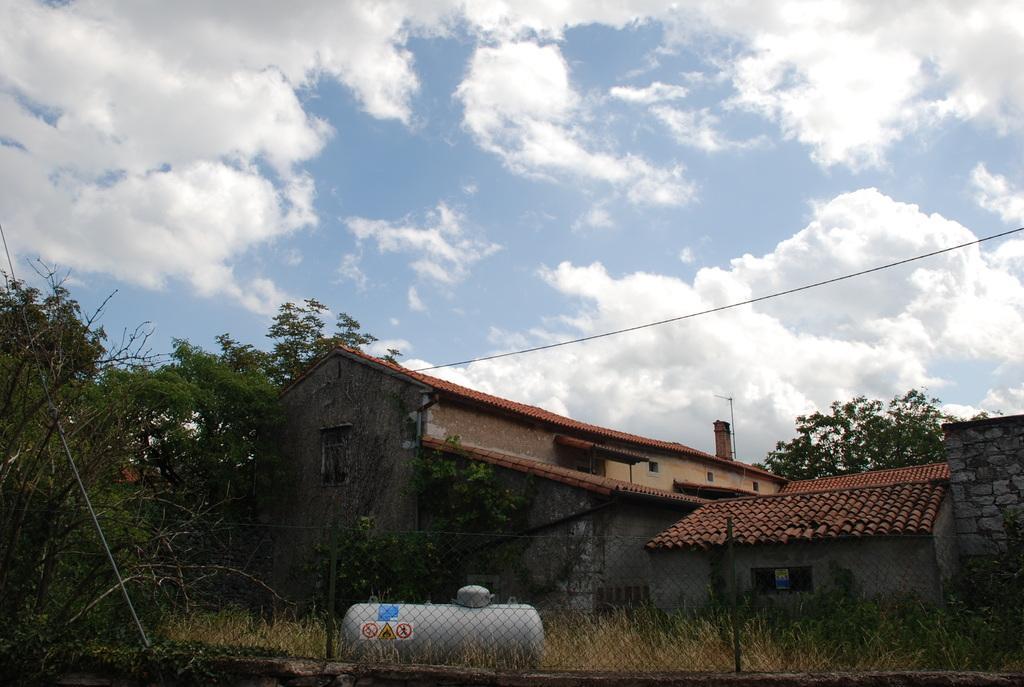Could you give a brief overview of what you see in this image? In this image there are sheds and we can see trees. At the bottom there is a fence and we can see a tanker. In the background there is sky and we can see a wire. 